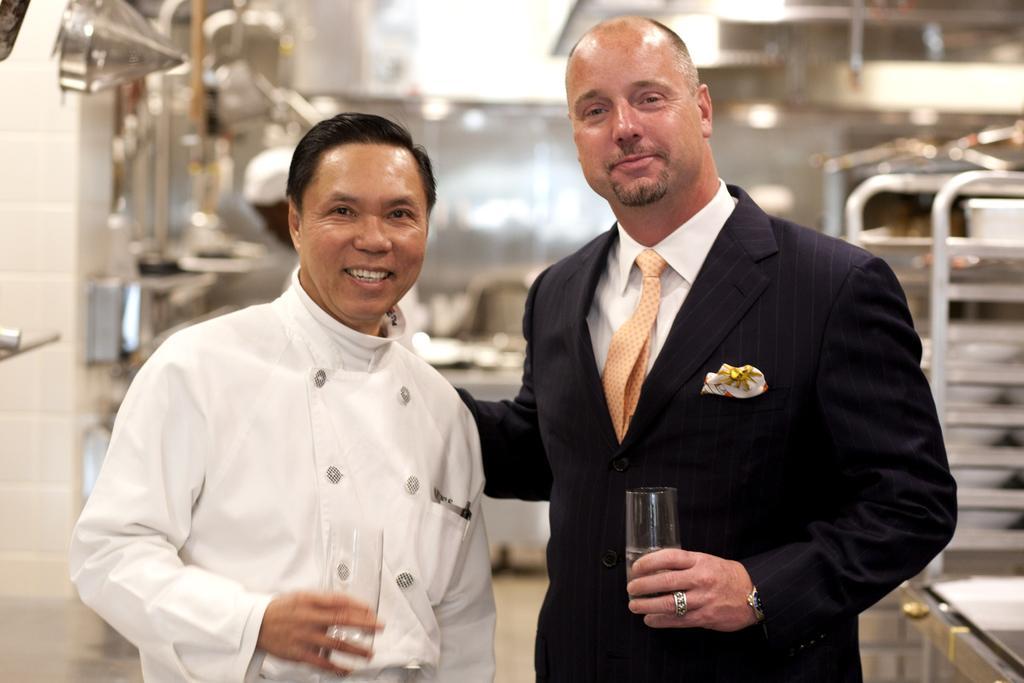Describe this image in one or two sentences. In this image there are two men in the middle who are holding the glasses. In the background there is a kitchen. On the left side there is a chef who is holding the glass. 